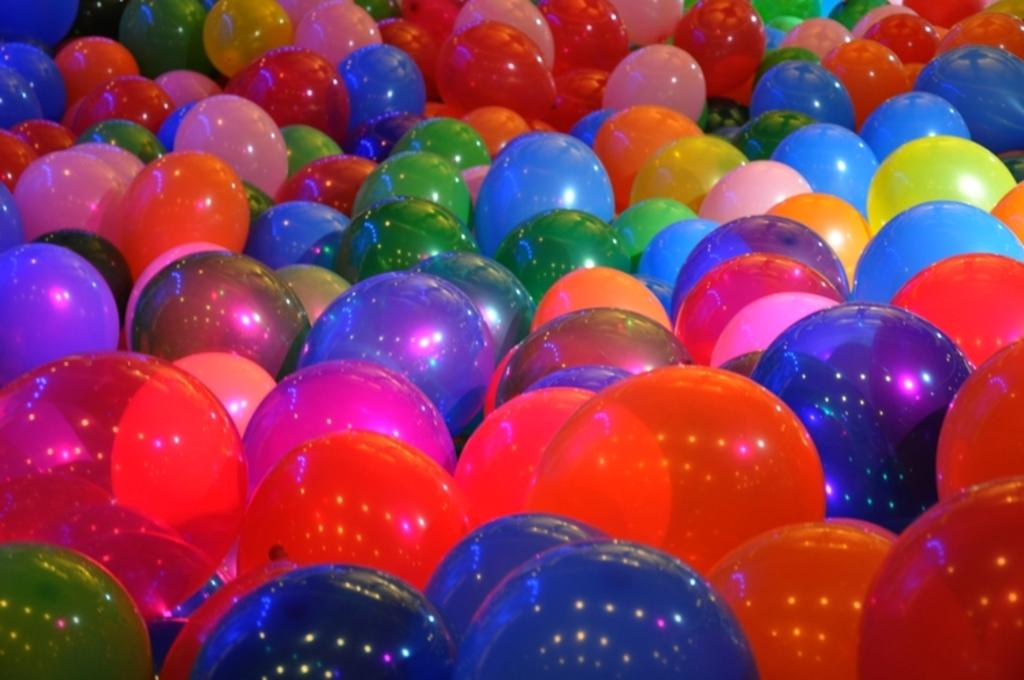What is the main subject of the image? The main subject of the image is a group of balloons. Can you describe the balloons in the image? The image shows a group of balloons, but it does not provide any specific details about their size, color, or shape. Are there any other objects or figures in the image? The facts provided do not mention any other objects or figures in the image, so we can only focus on the group of balloons. How does the person in the image feel about their brother? There is no person or mention of a brother in the image, as it only features a group of balloons. 